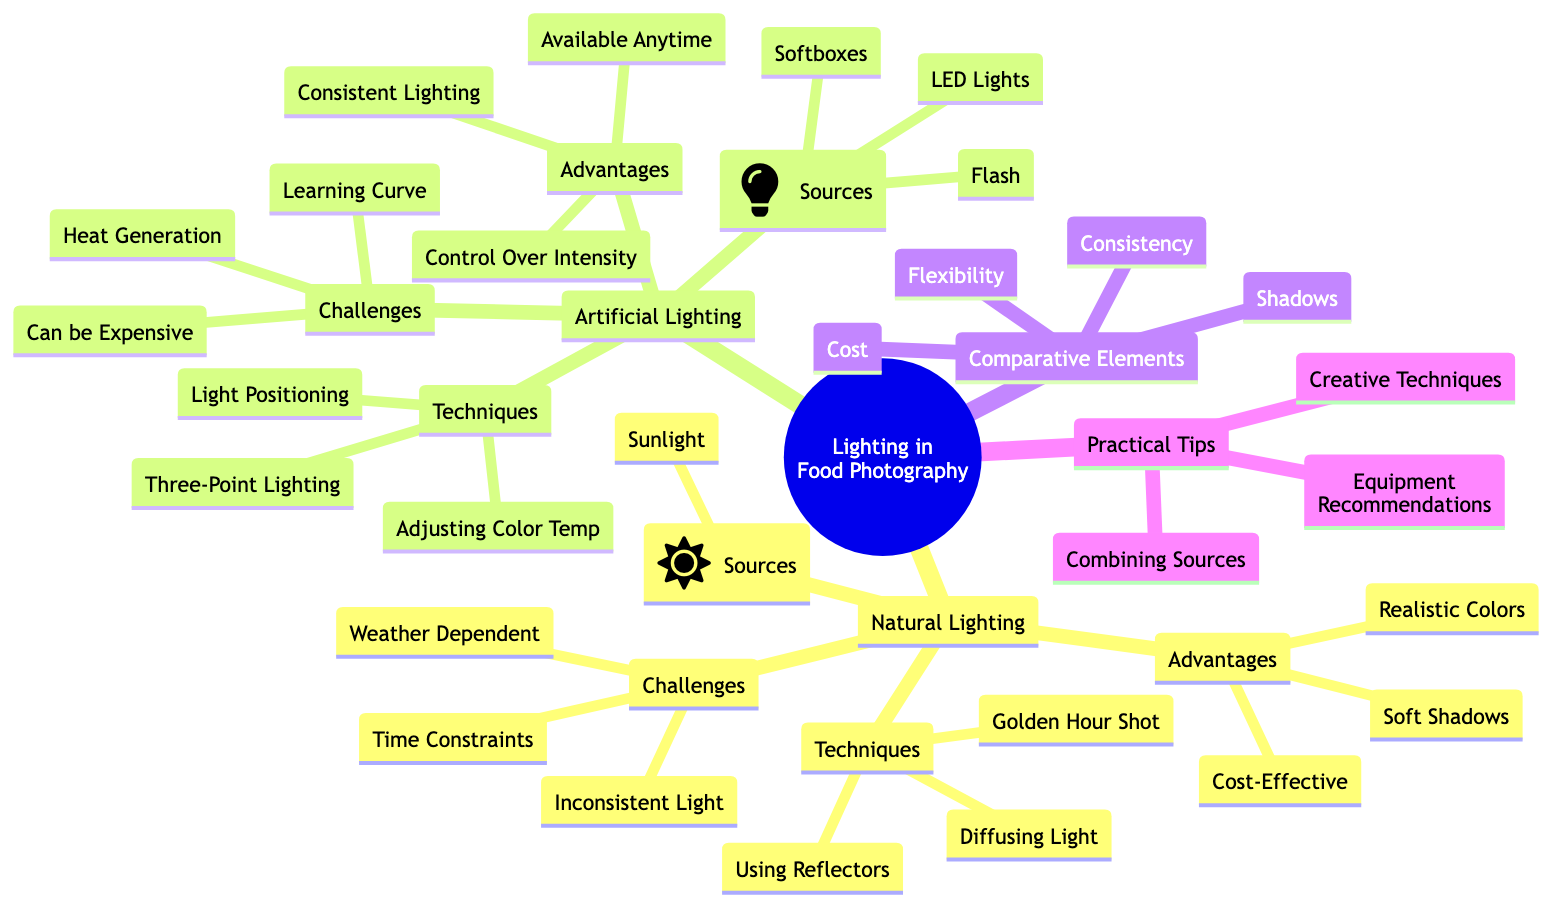What are the sources of Natural Lighting? The diagram lists "Sunlight" as the only source under the "Natural Lighting" category. This information can be found directly under the corresponding node.
Answer: Sunlight What is one advantage of Artificial Lighting? The advantages of Artificial Lighting include "Consistent Lighting", "Control Over Intensity", and "Available Anytime". Any of these can be stated, but one can be chosen as a representative example for this answer.
Answer: Consistent Lighting Name a challenge associated with Natural Lighting. The challenges mentioned for Natural Lighting include "Weather Dependent", "Time of Day Constraints", and "Inconsistent Light". Any of these phrases can serve as the answer, but one example suffices to answer the question.
Answer: Weather Dependent What technique is used to enhance Natural Light? The diagram states "Enhance Natural Light with Reflectors" as a technique under "Practical Tips". This information can be traced directly to the relevant node in the diagram.
Answer: Enhance Natural Light with Reflectors How does the flexibility of Natural Lighting compare to Artificial Lighting? The diagram indicates that Natural Lighting has "Limited" flexibility, while Artificial Lighting has "High" flexibility. To answer this, one can simply cite the corresponding descriptors from the "Comparative Elements" section.
Answer: Limited vs. High What type of lighting technique is used for texture? The diagram mentions "Side Lighting for Texture" as part of the "Creative Techniques" under "Practical Tips". This detail can be directly referenced for the answer.
Answer: Side Lighting for Texture Which lighting type is affected by weather conditions? The diagram specifies that "Natural Lighting" is "Weather Dependent", highlighting its susceptibility to external conditions as opposed to Artificial Lighting.
Answer: Natural Lighting What are the sources of Artificial Lighting? The sources listed under Artificial Lighting include "LED Lights", "Softboxes", and "Flash". The answer can be provided as a concise phrase of examples.
Answer: LED Lights, Softboxes, Flash 